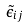Convert formula to latex. <formula><loc_0><loc_0><loc_500><loc_500>\tilde { \epsilon } _ { i j }</formula> 